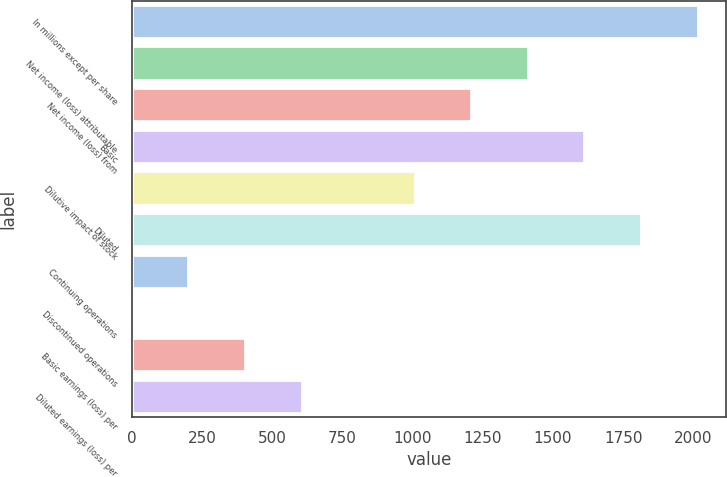<chart> <loc_0><loc_0><loc_500><loc_500><bar_chart><fcel>In millions except per share<fcel>Net income (loss) attributable<fcel>Net income (loss) from<fcel>Basic<fcel>Dilutive impact of stock<fcel>Diluted<fcel>Continuing operations<fcel>Discontinued operations<fcel>Basic earnings (loss) per<fcel>Diluted earnings (loss) per<nl><fcel>2015<fcel>1410.49<fcel>1209<fcel>1611.98<fcel>1007.51<fcel>1813.47<fcel>201.55<fcel>0.06<fcel>403.04<fcel>604.53<nl></chart> 